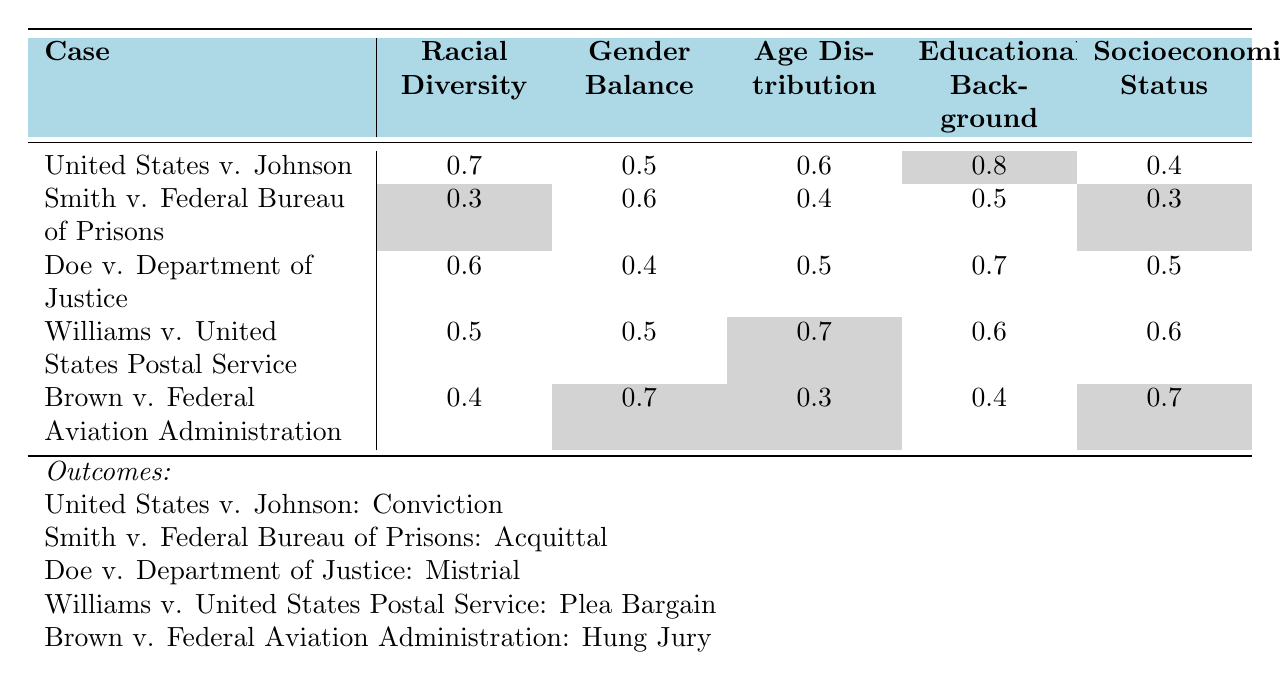What is the outcome of the case "Doe v. Department of Justice"? By looking at the last section of the table, it shows that the outcome for "Doe v. Department of Justice" is listed as "Mistrial."
Answer: Mistrial Which case has the highest racial diversity score? The table shows the racial diversity scores for all cases, and "United States v. Johnson" has the highest score of 0.7.
Answer: United States v. Johnson What is the gender balance score for "Smith v. Federal Bureau of Prisons"? The table indicates that the gender balance score for "Smith v. Federal Bureau of Prisons" is 0.6.
Answer: 0.6 What is the average educational background score across all cases? To find the average, add the educational background scores: (0.8 + 0.5 + 0.7 + 0.6 + 0.4) = 3.0. Then divide by the number of cases (5), which gives 3.0/5 = 0.6.
Answer: 0.6 Did "Williams v. United States Postal Service" result in a conviction? Looking at the outcome listed for "Williams v. United States Postal Service," it is stated as a "Plea Bargain," which means it did not result in a conviction.
Answer: No Which case has the lowest socioeconomic status score? Comparing the socioeconomic status scores in the table, "Smith v. Federal Bureau of Prisons" has the lowest score of 0.3.
Answer: Smith v. Federal Bureau of Prisons Is there a case with both a racial diversity score and a gender balance score above 0.6? Checking the scores, "United States v. Johnson" (0.7 racial diversity and 0.5 gender balance) and "Doe v. Department of Justice" (0.6 racial diversity and 0.4 gender balance) don't meet this condition. However, "Williams v. United States Postal Service" has a racial diversity of 0.5 and gender balance of 0.5, and "Brown v. Federal Aviation Administration" has 0.4 and 0.7 respectively, still, none meet the criteria of both above 0.6.
Answer: No If you average the age distribution scores, what would the result be? To calculate the average: (0.6 + 0.4 + 0.5 + 0.7 + 0.3) = 2.5. Then divide by the number of cases (5), resulting in 2.5/5 = 0.5.
Answer: 0.5 Which case experienced a hung jury and what was its racial diversity score? "Brown v. Federal Aviation Administration" is indicated as experiencing a hung jury, and its racial diversity score is 0.4.
Answer: Brown v. Federal Aviation Administration, 0.4 Is there a positive correlation between educational background and conviction cases? Analyzing, "United States v. Johnson" with a high educational score of 0.8 ended in a conviction, whereas "Smith v. Federal Bureau of Prisons," which has a lower score of 0.5, resulted in an acquittal. However, "Doe v. Department of Justice" (0.7) led to a mistrial and "Williams" (0.6) resulted in a plea bargain, making it unclear if there is a definitive correlation just based on this small dataset.
Answer: No, correlation unclear 